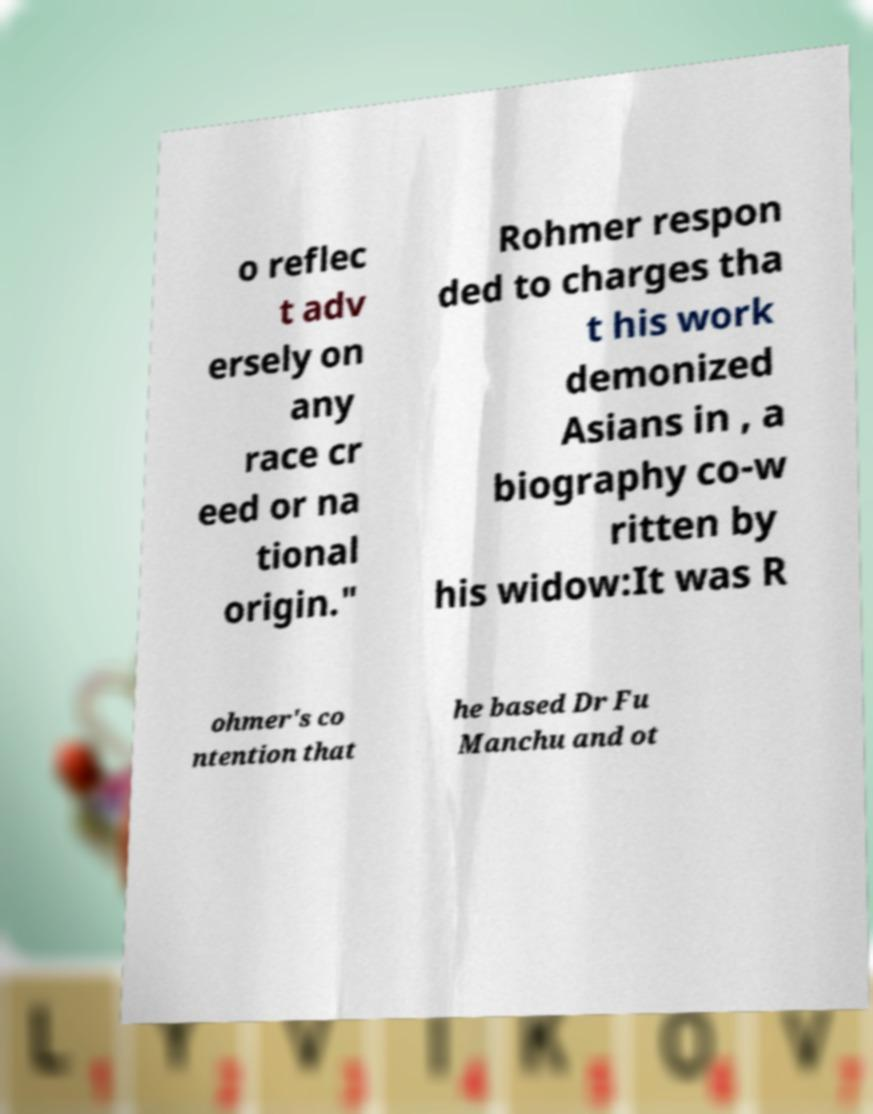Could you extract and type out the text from this image? o reflec t adv ersely on any race cr eed or na tional origin." Rohmer respon ded to charges tha t his work demonized Asians in , a biography co-w ritten by his widow:It was R ohmer's co ntention that he based Dr Fu Manchu and ot 